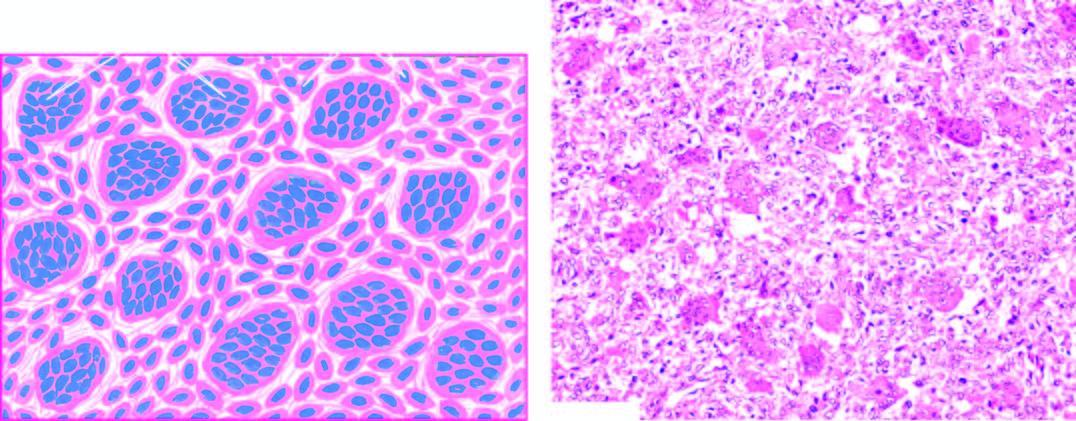does the tumour arising from the retina reveal osteoclast-like multinucleate giant cells which are regularly distributed among the mononuclear stromal cells?
Answer the question using a single word or phrase. No 